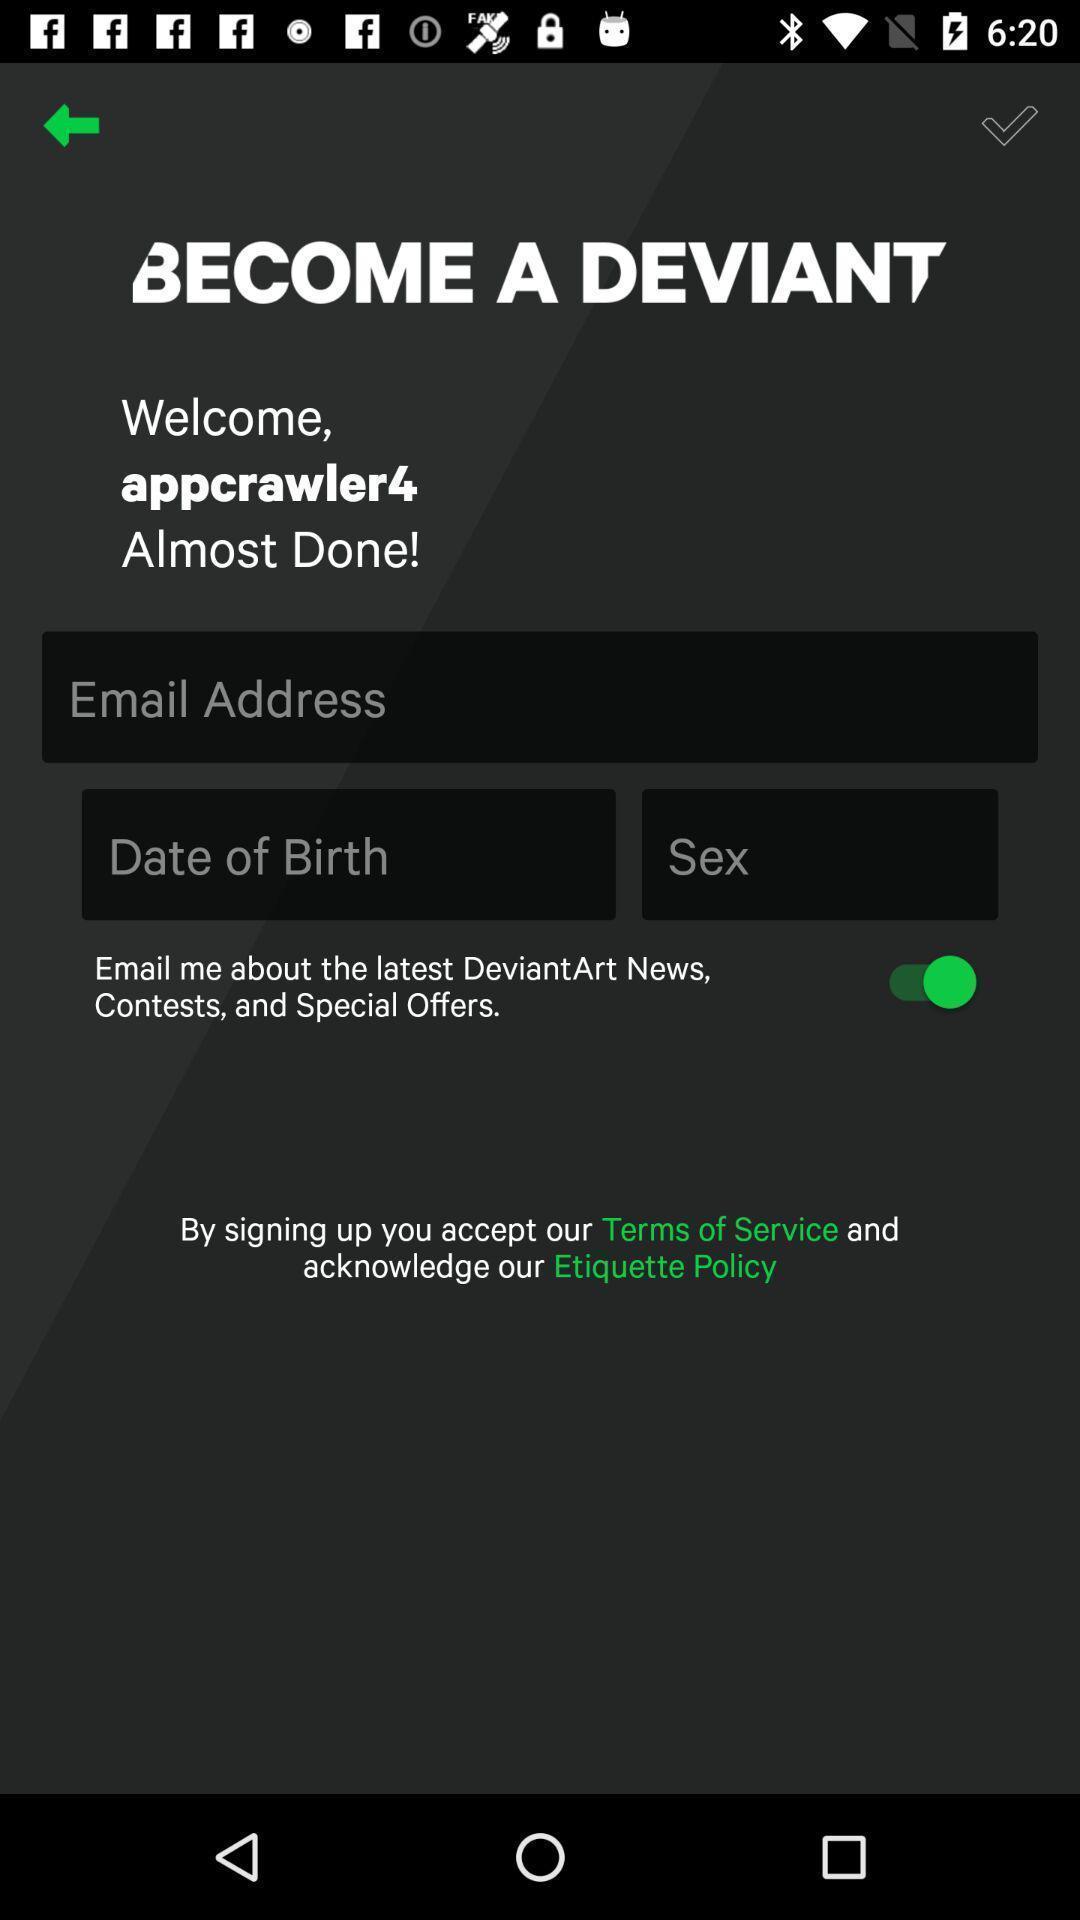Explain the elements present in this screenshot. Welcome page with login credentials. 